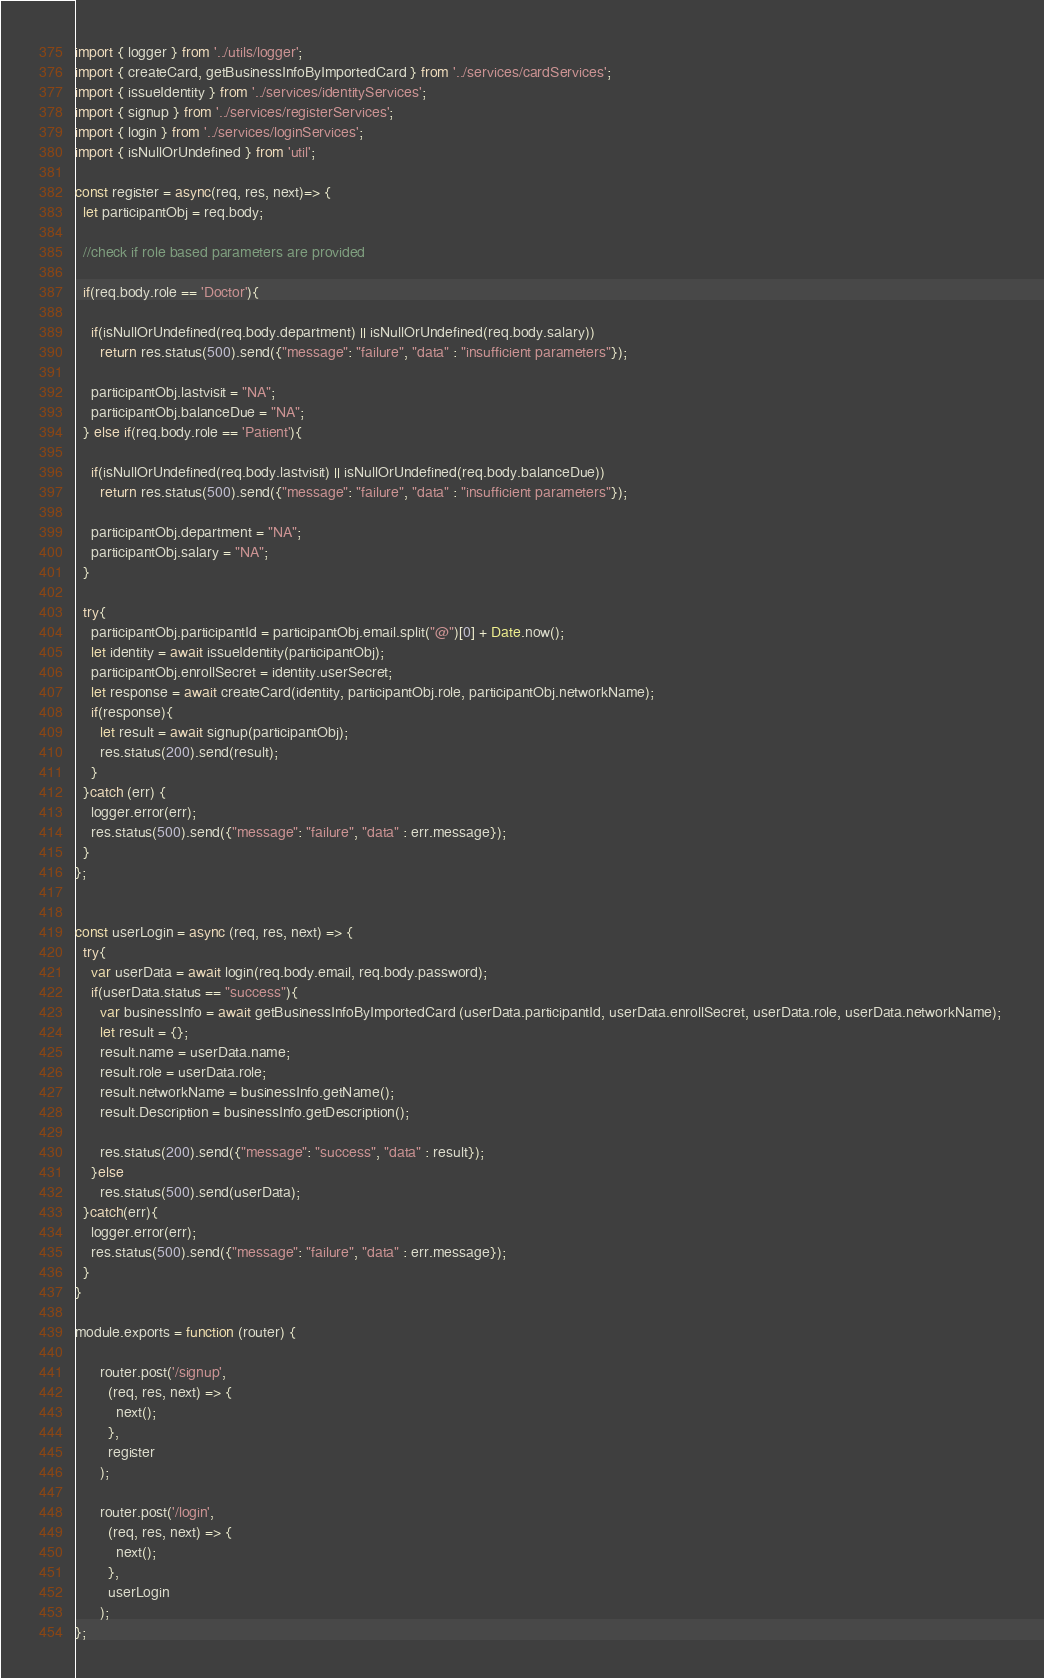Convert code to text. <code><loc_0><loc_0><loc_500><loc_500><_JavaScript_>import { logger } from '../utils/logger';
import { createCard, getBusinessInfoByImportedCard } from '../services/cardServices';
import { issueIdentity } from '../services/identityServices';
import { signup } from '../services/registerServices';
import { login } from '../services/loginServices';
import { isNullOrUndefined } from 'util';

const register = async(req, res, next)=> {
  let participantObj = req.body;
  
  //check if role based parameters are provided

  if(req.body.role == 'Doctor'){
    
    if(isNullOrUndefined(req.body.department) || isNullOrUndefined(req.body.salary))
      return res.status(500).send({"message": "failure", "data" : "insufficient parameters"});
    
    participantObj.lastvisit = "NA";
    participantObj.balanceDue = "NA";
  } else if(req.body.role == 'Patient'){

    if(isNullOrUndefined(req.body.lastvisit) || isNullOrUndefined(req.body.balanceDue))
      return res.status(500).send({"message": "failure", "data" : "insufficient parameters"});
    
    participantObj.department = "NA";
    participantObj.salary = "NA";
  }

  try{
    participantObj.participantId = participantObj.email.split("@")[0] + Date.now();
    let identity = await issueIdentity(participantObj);
    participantObj.enrollSecret = identity.userSecret;
    let response = await createCard(identity, participantObj.role, participantObj.networkName);
    if(response){
      let result = await signup(participantObj);
      res.status(200).send(result);
    }
  }catch (err) {
    logger.error(err);
    res.status(500).send({"message": "failure", "data" : err.message});
  }     
};


const userLogin = async (req, res, next) => {
  try{
    var userData = await login(req.body.email, req.body.password);
    if(userData.status == "success"){
      var businessInfo = await getBusinessInfoByImportedCard (userData.participantId, userData.enrollSecret, userData.role, userData.networkName); 
      let result = {};
      result.name = userData.name;
      result.role = userData.role;
      result.networkName = businessInfo.getName();
      result.Description = businessInfo.getDescription();     
      
      res.status(200).send({"message": "success", "data" : result});
    }else
      res.status(500).send(userData);
  }catch(err){
    logger.error(err);
    res.status(500).send({"message": "failure", "data" : err.message});
  }
}

module.exports = function (router) {

      router.post('/signup',
        (req, res, next) => {
          next();
        },
        register
      ); 
      
      router.post('/login',
        (req, res, next) => {
          next();
        },
        userLogin
      );
};</code> 